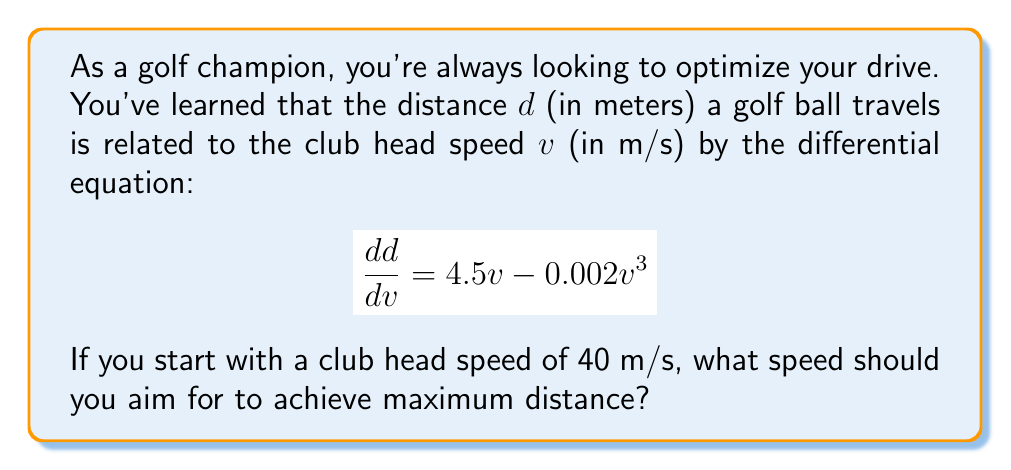Provide a solution to this math problem. To find the optimal club head speed for maximum distance, we need to find the value of $v$ where $\frac{dd}{dv}$ is at its maximum. This occurs when the derivative of $\frac{dd}{dv}$ with respect to $v$ equals zero.

1) First, let's differentiate $\frac{dd}{dv}$ with respect to $v$:

   $$\frac{d}{dv}\left(\frac{dd}{dv}\right) = \frac{d}{dv}(4.5v - 0.002v^3)$$
   $$= 4.5 - 0.006v^2$$

2) Now, we set this equal to zero and solve for $v$:

   $$4.5 - 0.006v^2 = 0$$
   $$0.006v^2 = 4.5$$
   $$v^2 = \frac{4.5}{0.006} = 750$$
   $$v = \sqrt{750} \approx 27.39 \text{ m/s}$$

3) To confirm this is a maximum (not a minimum), we can check the second derivative:

   $$\frac{d^2}{dv^2}\left(\frac{dd}{dv}\right) = -0.012v$$

   This is negative for positive $v$, confirming we have found a maximum.

4) Therefore, the optimal club head speed for maximum distance is approximately 27.39 m/s.

5) Since you start with a club head speed of 40 m/s, you should aim to reduce your club head speed to achieve maximum distance.
Answer: The optimal club head speed for maximum distance is approximately 27.39 m/s. You should aim to reduce your initial club head speed of 40 m/s to this optimal speed. 